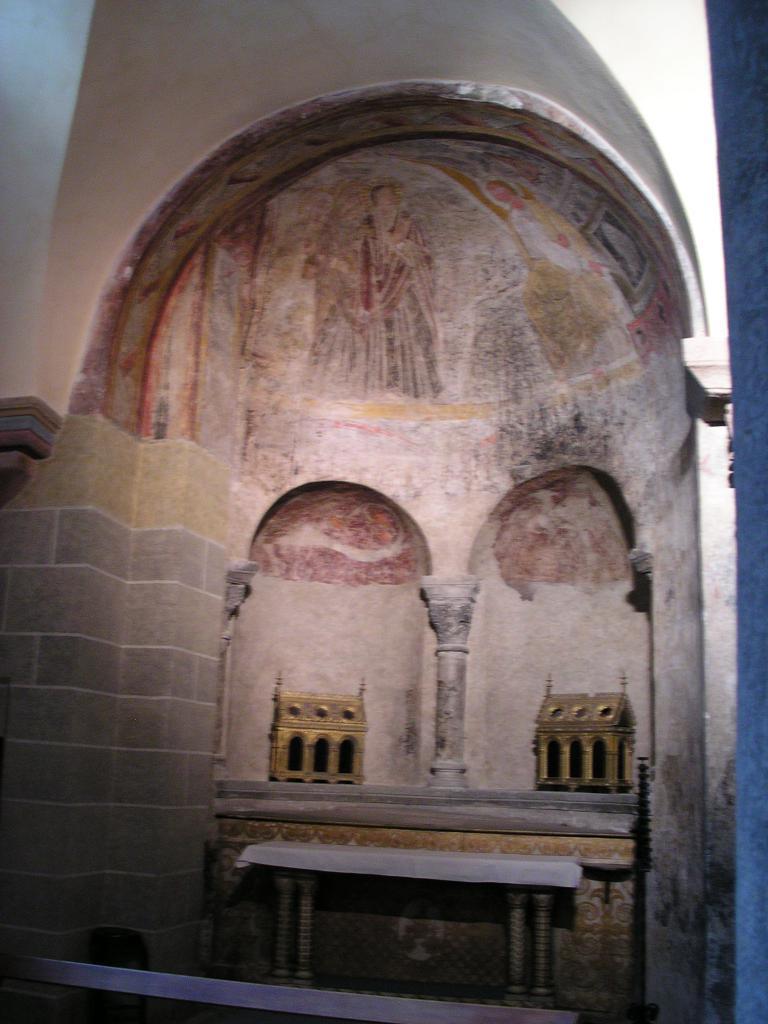Please provide a concise description of this image. In front of the image there is a table. Behind the table there are some objects on the platform. In the background of the image there is a painting on the wall. 